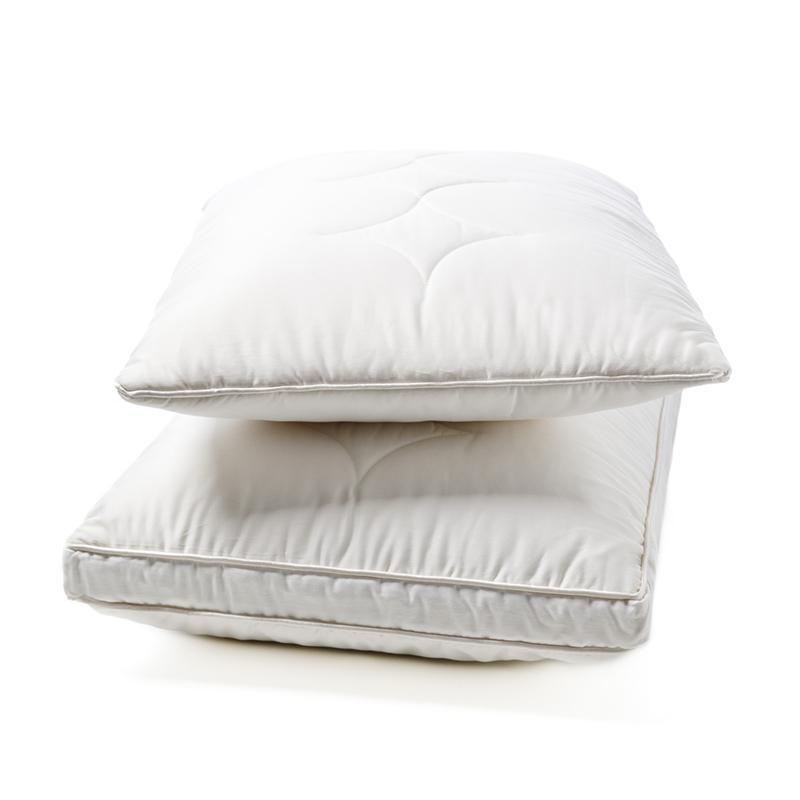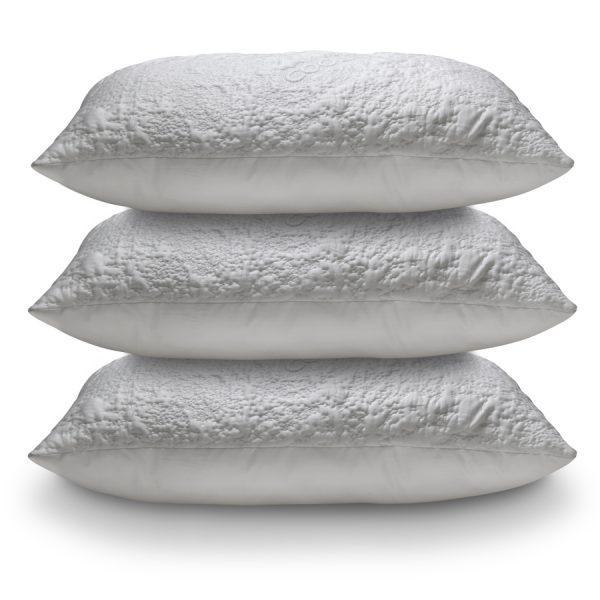The first image is the image on the left, the second image is the image on the right. Examine the images to the left and right. Is the description "The left image contains a stack of four pillows and the right image contains a stack of two pillows." accurate? Answer yes or no. No. The first image is the image on the left, the second image is the image on the right. Assess this claim about the two images: "The right image contains two  white pillows stacked vertically on top of each other.". Correct or not? Answer yes or no. No. 